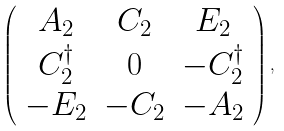Convert formula to latex. <formula><loc_0><loc_0><loc_500><loc_500>\left ( \begin{array} { c c c } { { A _ { 2 } } } & { { C _ { 2 } } } & { { E _ { 2 } } } \\ { { C _ { 2 } ^ { \dagger } } } & { 0 } & { { - C _ { 2 } ^ { \dagger } } } \\ { { - E _ { 2 } } } & { { - C _ { 2 } } } & { { - A _ { 2 } } } \end{array} \right ) ,</formula> 